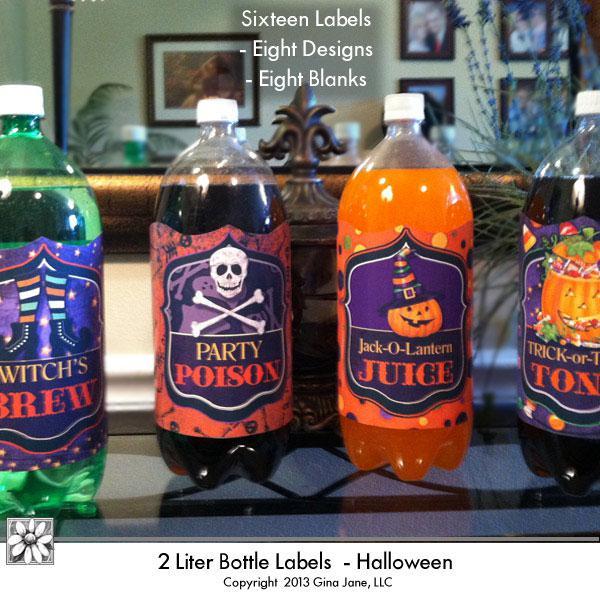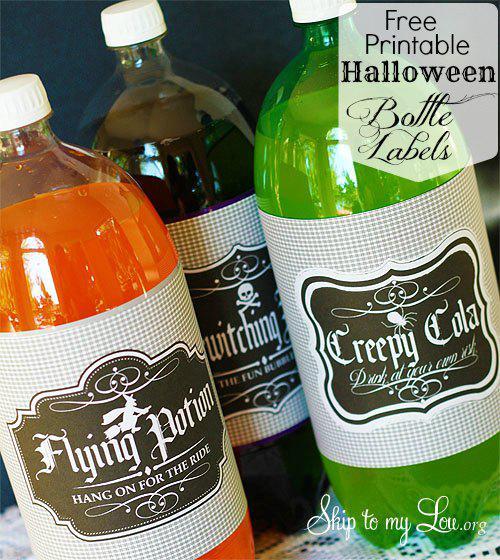The first image is the image on the left, the second image is the image on the right. Analyze the images presented: Is the assertion "There are only three bottles visible in one of the images." valid? Answer yes or no. Yes. 